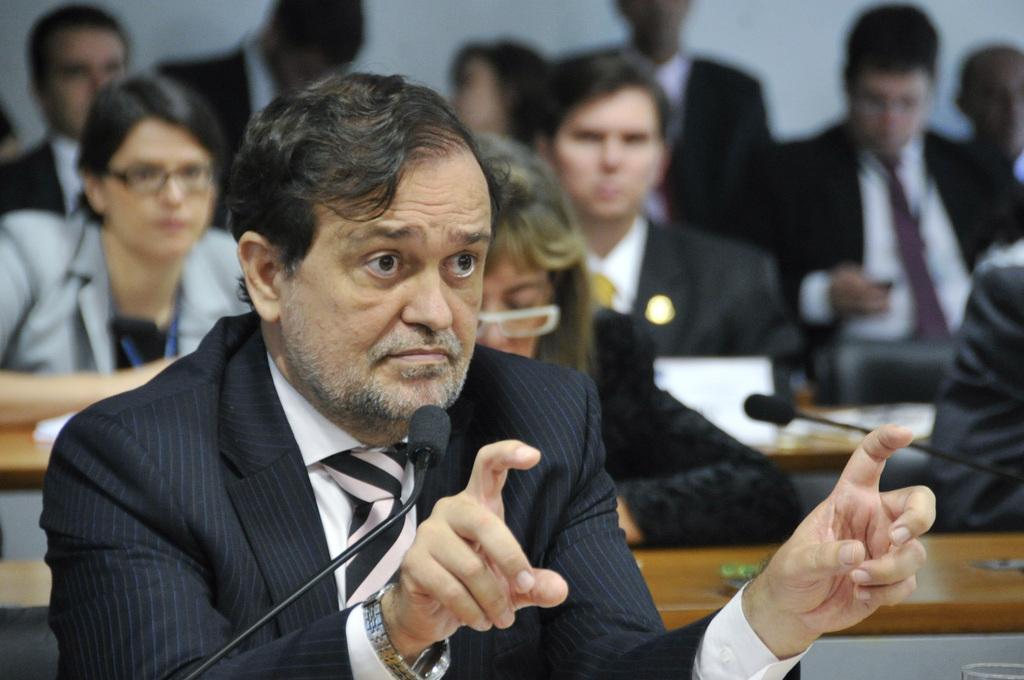Could you give a brief overview of what you see in this image? In this picture we can see a group of people, here we can see mics, tables and some objects and we can see a wall in the background. 